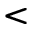Convert formula to latex. <formula><loc_0><loc_0><loc_500><loc_500><</formula> 